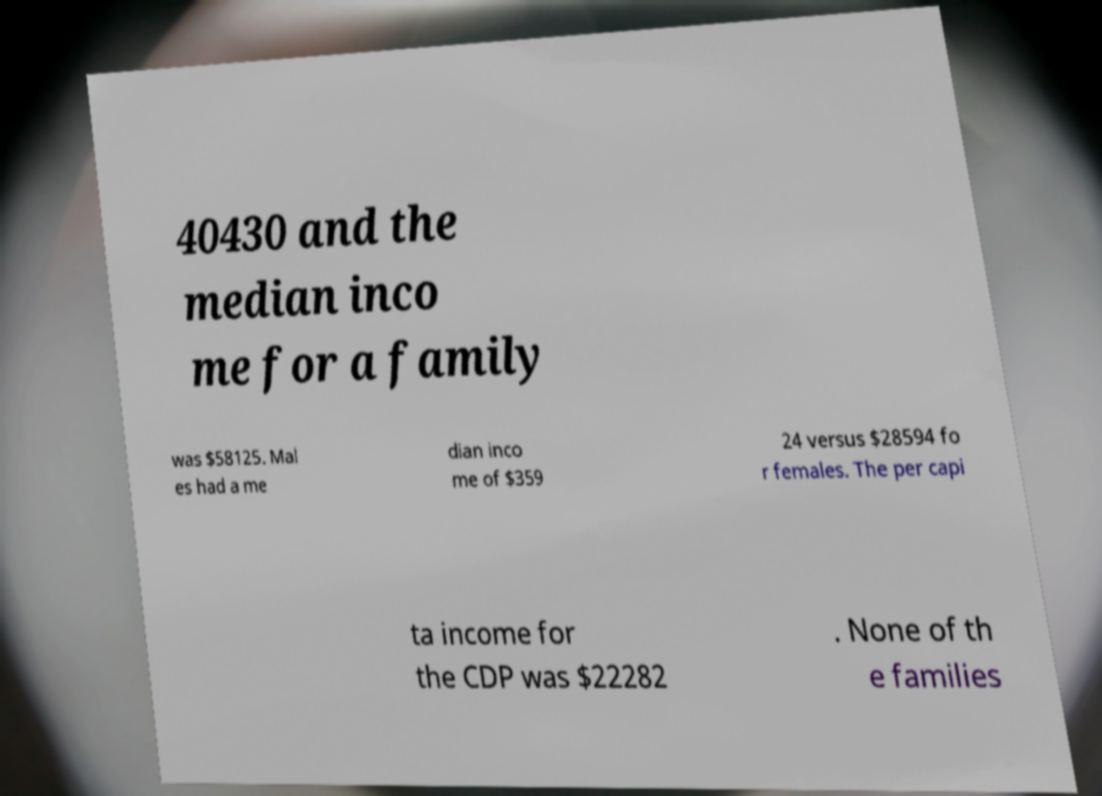Please read and relay the text visible in this image. What does it say? 40430 and the median inco me for a family was $58125. Mal es had a me dian inco me of $359 24 versus $28594 fo r females. The per capi ta income for the CDP was $22282 . None of th e families 